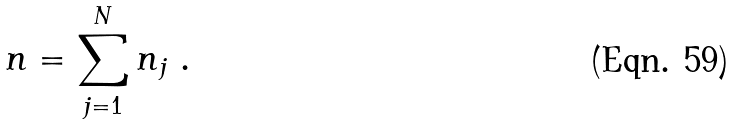Convert formula to latex. <formula><loc_0><loc_0><loc_500><loc_500>n = \sum _ { j = 1 } ^ { N } n _ { j } \ .</formula> 